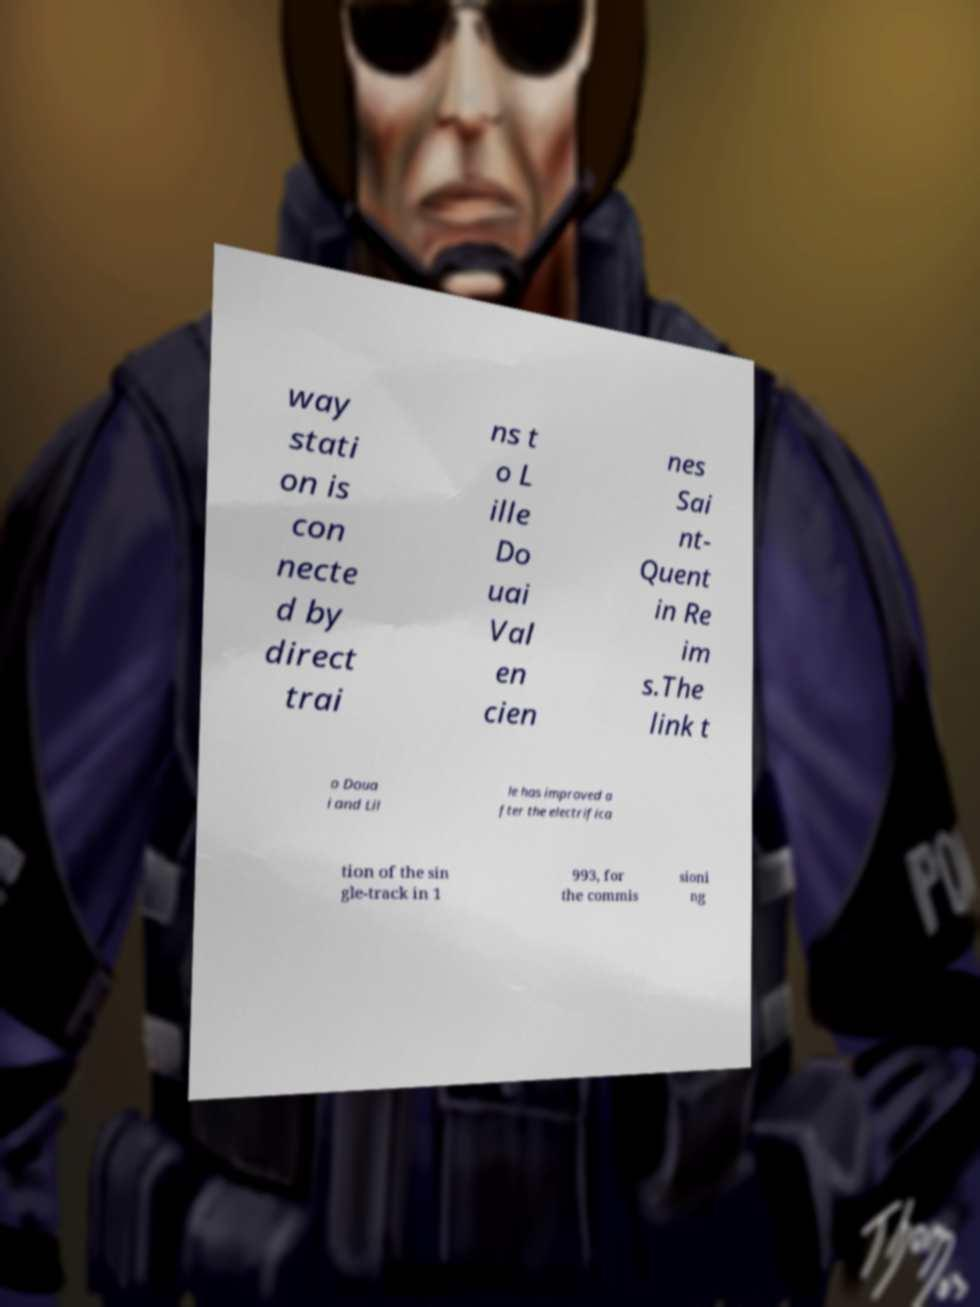What messages or text are displayed in this image? I need them in a readable, typed format. way stati on is con necte d by direct trai ns t o L ille Do uai Val en cien nes Sai nt- Quent in Re im s.The link t o Doua i and Lil le has improved a fter the electrifica tion of the sin gle-track in 1 993, for the commis sioni ng 